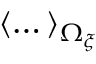Convert formula to latex. <formula><loc_0><loc_0><loc_500><loc_500>\left < \dots \right > _ { \Omega _ { \xi } }</formula> 